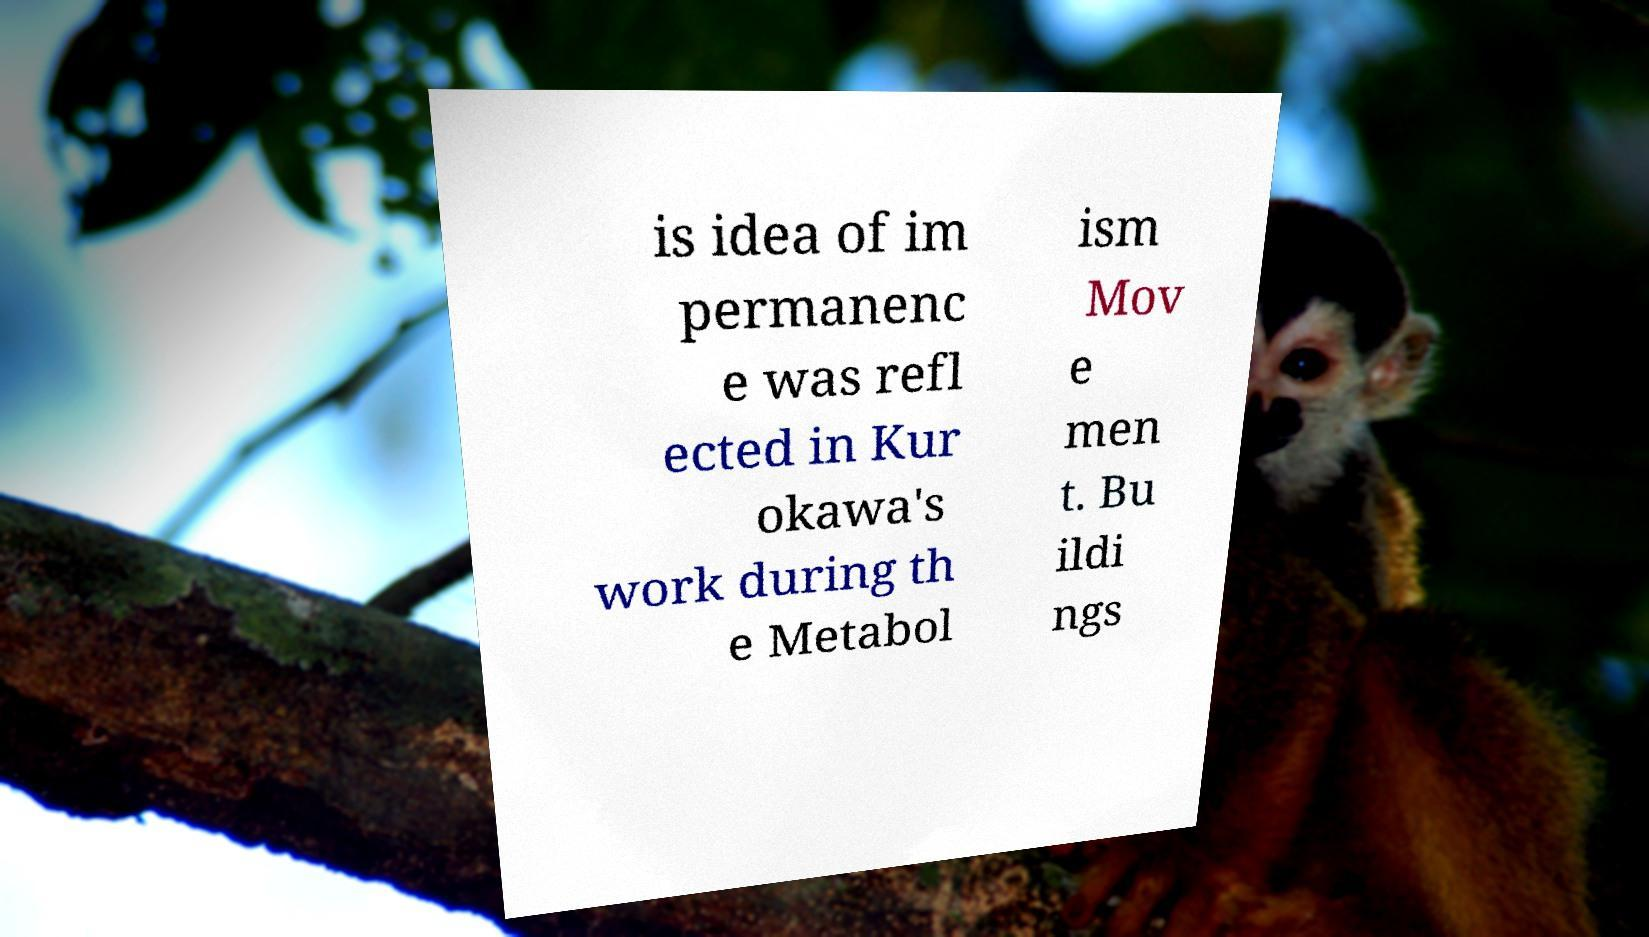What messages or text are displayed in this image? I need them in a readable, typed format. is idea of im permanenc e was refl ected in Kur okawa's work during th e Metabol ism Mov e men t. Bu ildi ngs 